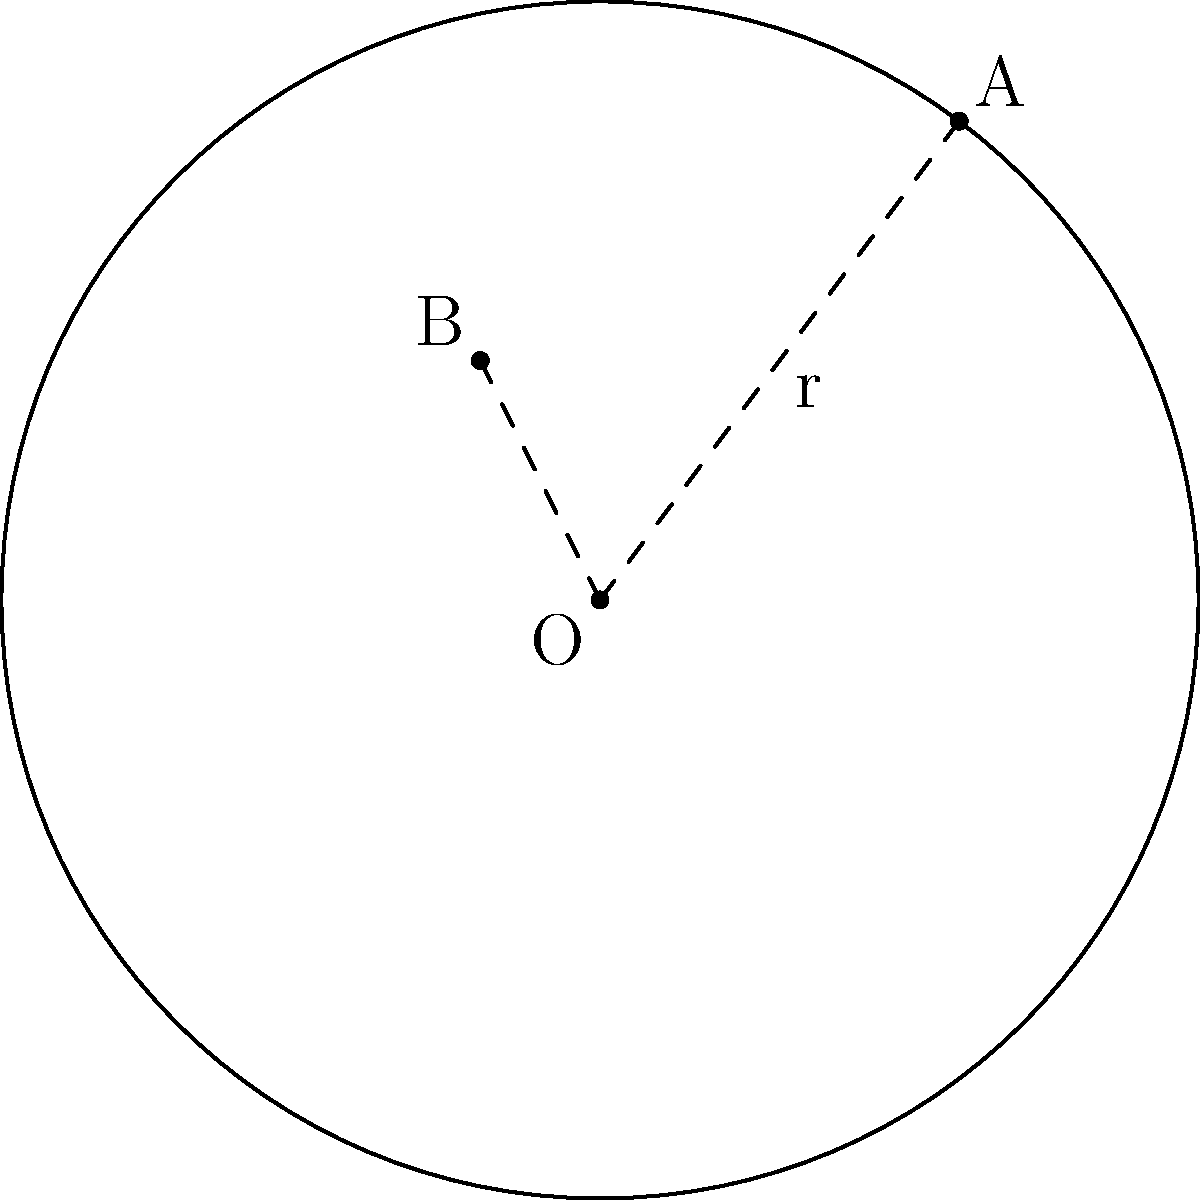In a robotic arm design for an automated badminton ball dispenser, a circular gear is used to control the turning radius of the arm. The center of the gear is at the origin (0,0), and two points A(3,4) and B(-1,2) lie on its circumference. Determine the equation of the circle representing this gear. Let's approach this step-by-step:

1) The general equation of a circle is $$(x-h)^2 + (y-k)^2 = r^2$$
   where (h,k) is the center and r is the radius.

2) We know the center is at (0,0), so h = 0 and k = 0. Our equation simplifies to:
   $$x^2 + y^2 = r^2$$

3) To find r, we can use either point A or B. Let's use A(3,4):
   $$3^2 + 4^2 = r^2$$
   $$9 + 16 = r^2$$
   $$25 = r^2$$
   $$r = 5$$

4) We can verify this using point B(-1,2):
   $$(-1)^2 + 2^2 = 1 + 4 = 5^2 = 25$$

5) Therefore, the equation of the circle is:
   $$x^2 + y^2 = 25$$
Answer: $x^2 + y^2 = 25$ 